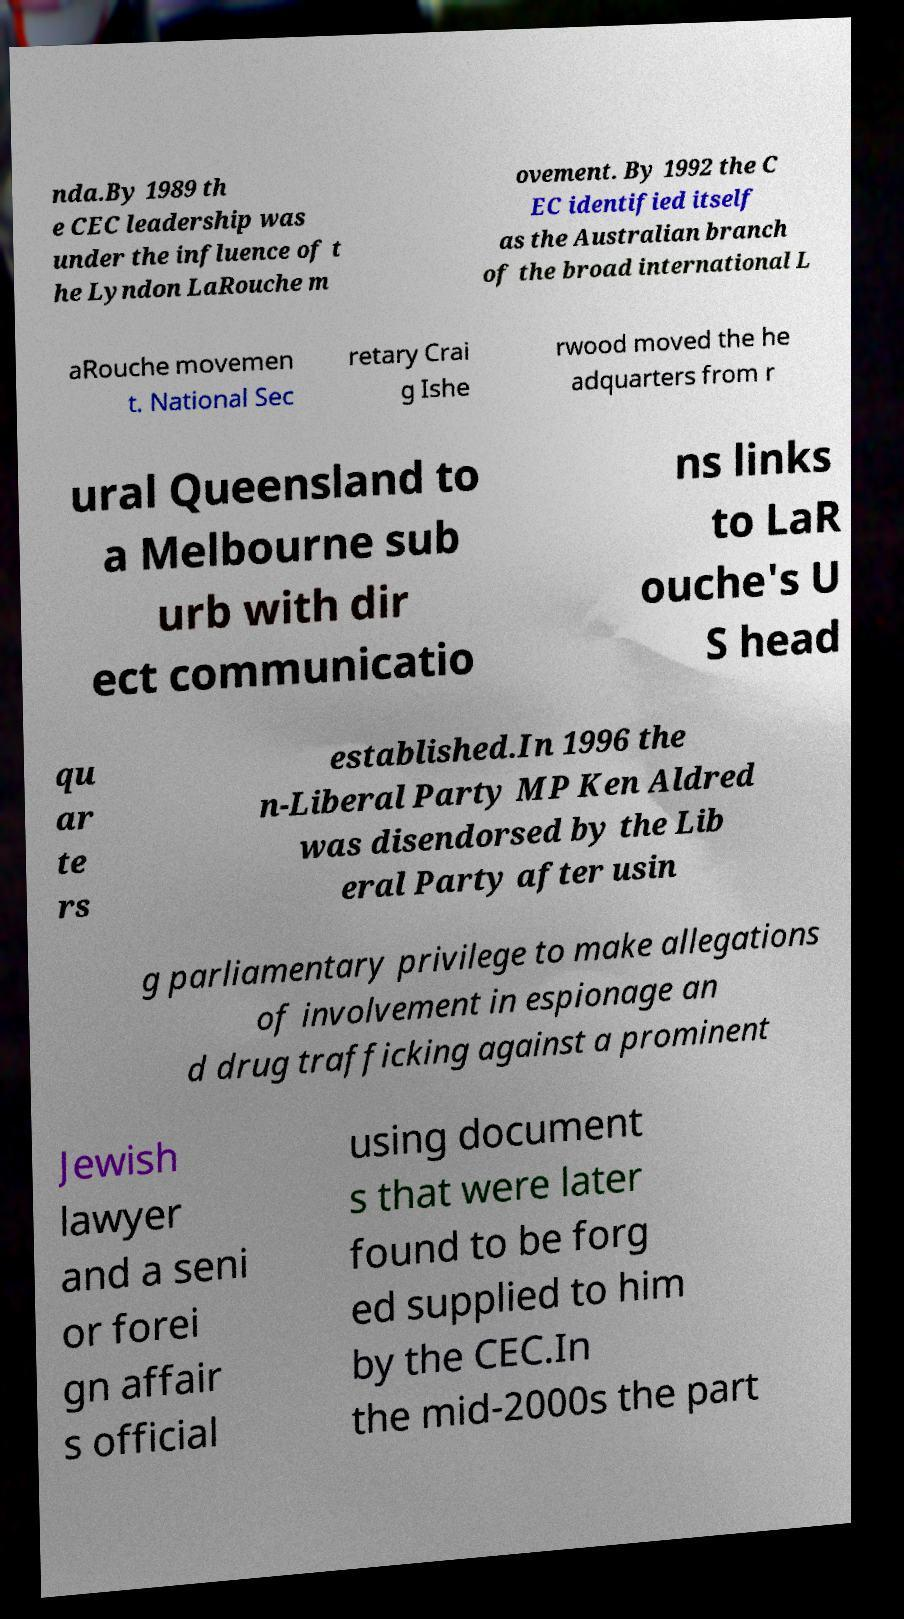Could you extract and type out the text from this image? nda.By 1989 th e CEC leadership was under the influence of t he Lyndon LaRouche m ovement. By 1992 the C EC identified itself as the Australian branch of the broad international L aRouche movemen t. National Sec retary Crai g Ishe rwood moved the he adquarters from r ural Queensland to a Melbourne sub urb with dir ect communicatio ns links to LaR ouche's U S head qu ar te rs established.In 1996 the n-Liberal Party MP Ken Aldred was disendorsed by the Lib eral Party after usin g parliamentary privilege to make allegations of involvement in espionage an d drug trafficking against a prominent Jewish lawyer and a seni or forei gn affair s official using document s that were later found to be forg ed supplied to him by the CEC.In the mid-2000s the part 